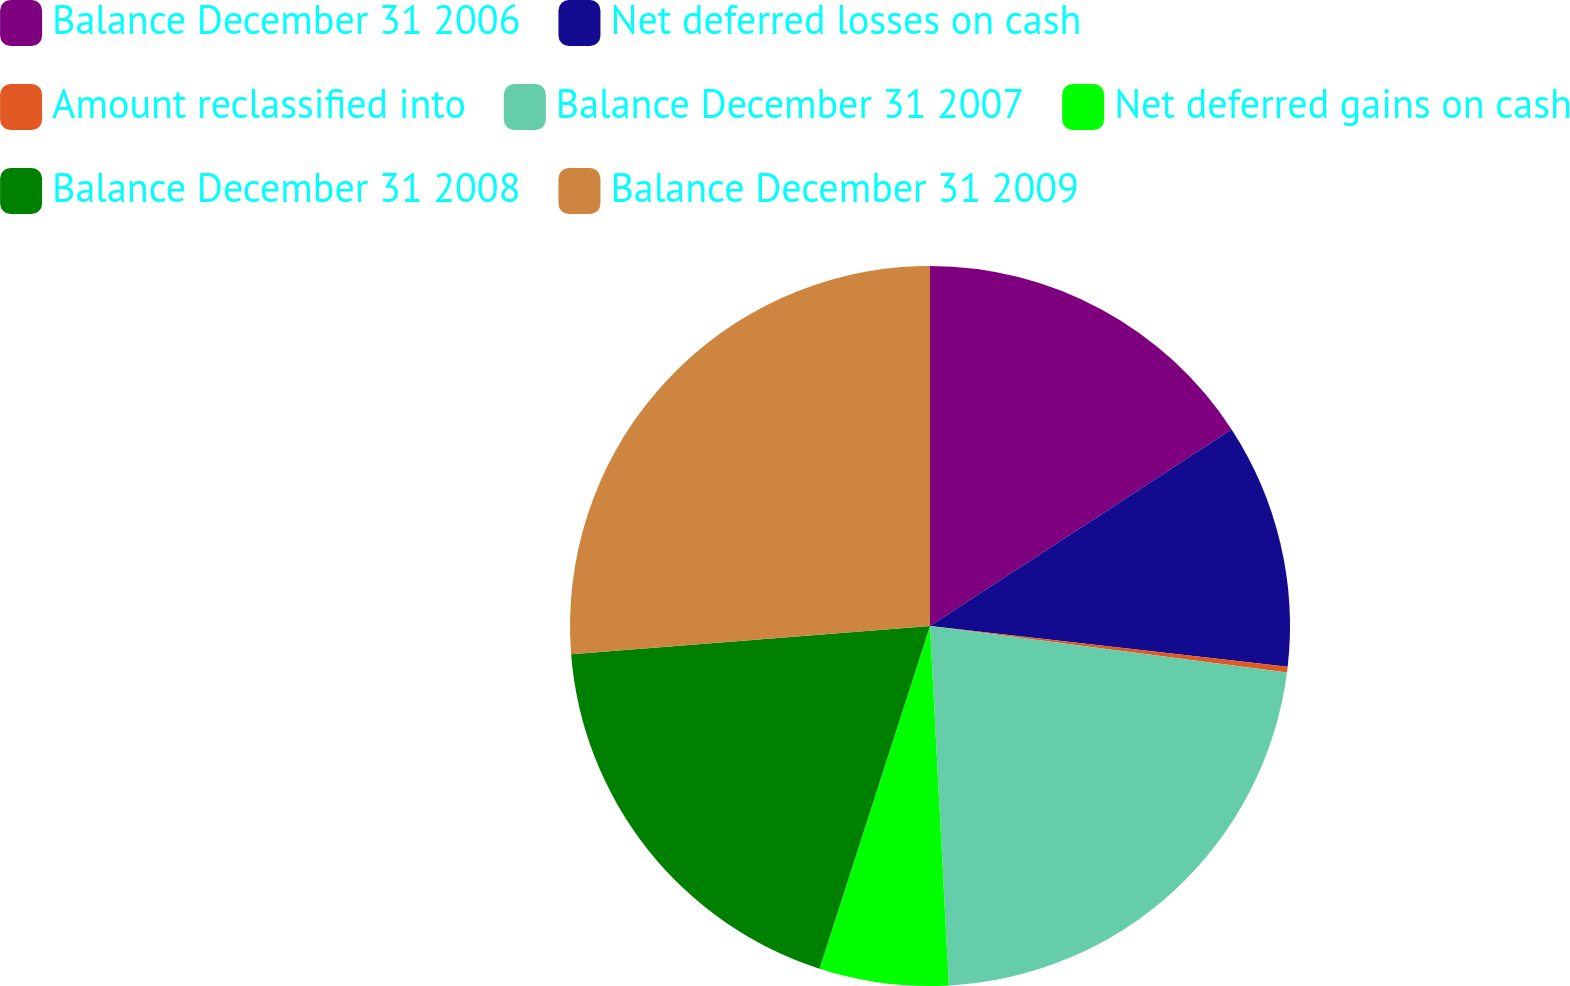Convert chart. <chart><loc_0><loc_0><loc_500><loc_500><pie_chart><fcel>Balance December 31 2006<fcel>Net deferred losses on cash<fcel>Amount reclassified into<fcel>Balance December 31 2007<fcel>Net deferred gains on cash<fcel>Balance December 31 2008<fcel>Balance December 31 2009<nl><fcel>15.81%<fcel>11.0%<fcel>0.25%<fcel>22.11%<fcel>5.8%<fcel>18.79%<fcel>26.25%<nl></chart> 